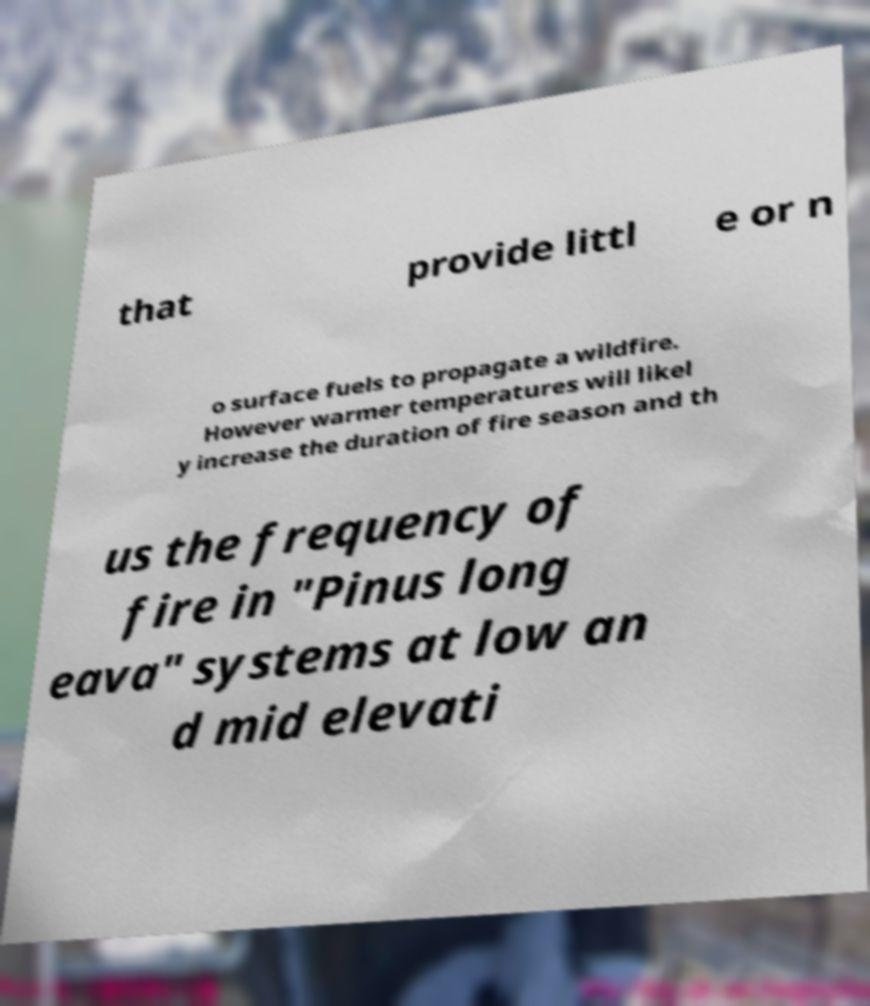Please identify and transcribe the text found in this image. that provide littl e or n o surface fuels to propagate a wildfire. However warmer temperatures will likel y increase the duration of fire season and th us the frequency of fire in "Pinus long eava" systems at low an d mid elevati 